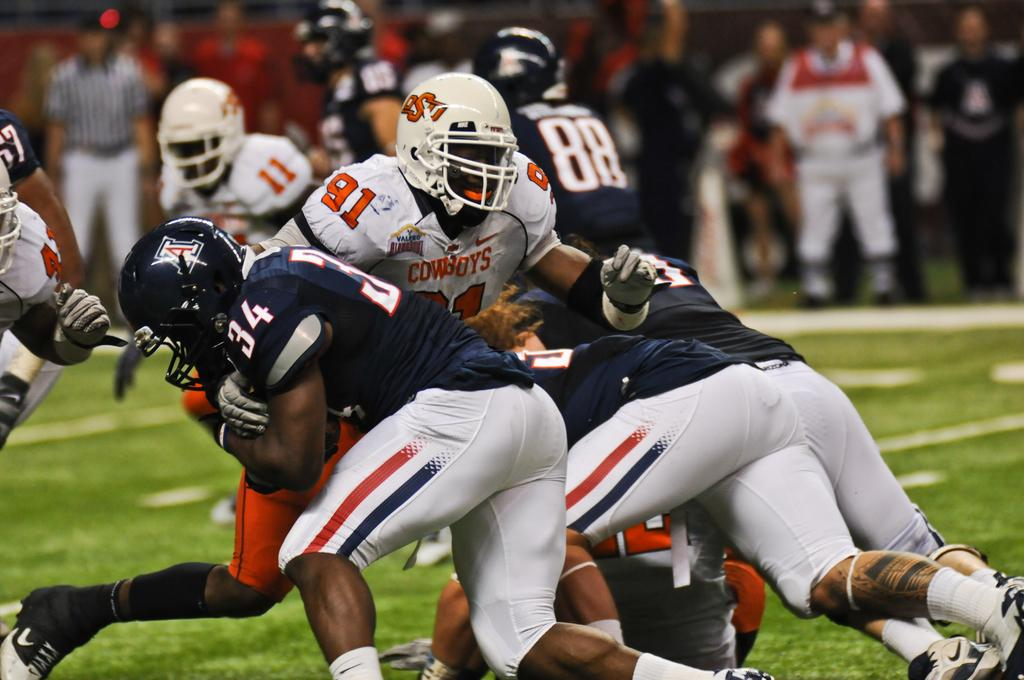What are the men in the image doing? The men in the image are playing. What are the men wearing while playing? The men are wearing jerseys and helmets. What is the surface they are playing on? There is grass on the ground. Are there any spectators or other people visible in the image? Yes, there are people standing in the background of the image. What type of mint is growing on the helmets of the men in the image? There is no mint growing on the helmets of the men in the image. 